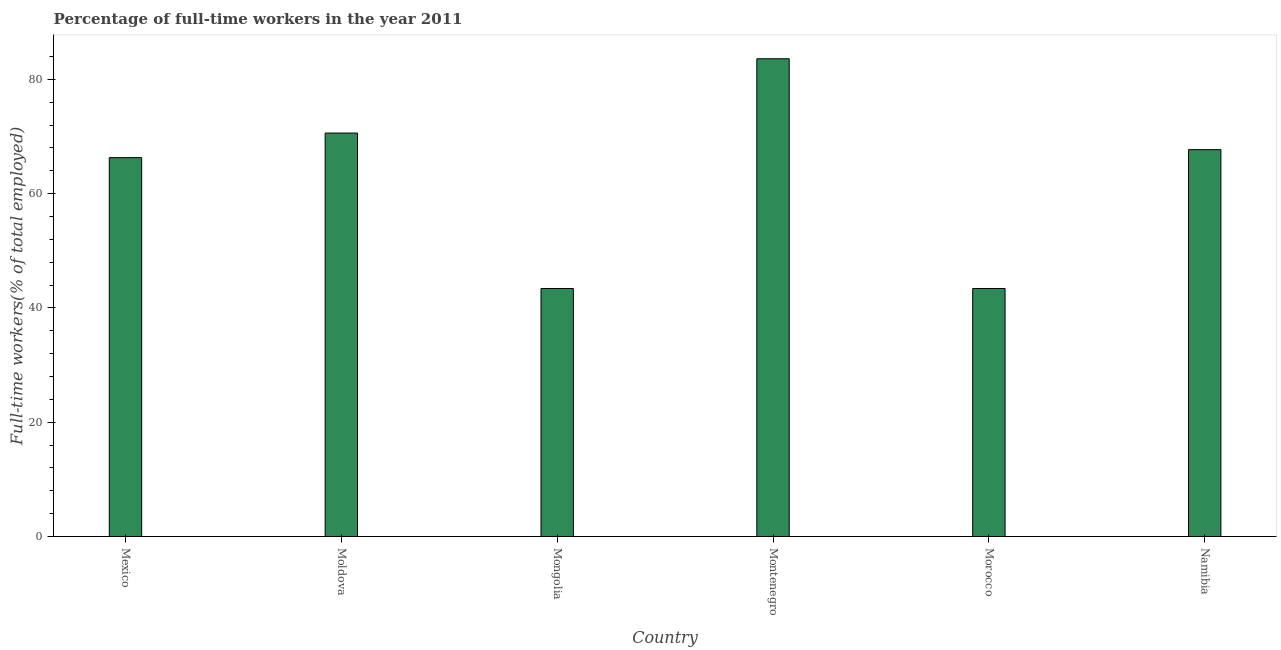Does the graph contain any zero values?
Make the answer very short. No. What is the title of the graph?
Give a very brief answer. Percentage of full-time workers in the year 2011. What is the label or title of the Y-axis?
Your response must be concise. Full-time workers(% of total employed). What is the percentage of full-time workers in Montenegro?
Provide a short and direct response. 83.6. Across all countries, what is the maximum percentage of full-time workers?
Your response must be concise. 83.6. Across all countries, what is the minimum percentage of full-time workers?
Your response must be concise. 43.4. In which country was the percentage of full-time workers maximum?
Your answer should be very brief. Montenegro. In which country was the percentage of full-time workers minimum?
Offer a terse response. Mongolia. What is the sum of the percentage of full-time workers?
Ensure brevity in your answer.  375. What is the difference between the percentage of full-time workers in Mongolia and Montenegro?
Offer a terse response. -40.2. What is the average percentage of full-time workers per country?
Keep it short and to the point. 62.5. What is the median percentage of full-time workers?
Ensure brevity in your answer.  67. In how many countries, is the percentage of full-time workers greater than 60 %?
Provide a succinct answer. 4. What is the ratio of the percentage of full-time workers in Moldova to that in Mongolia?
Your answer should be compact. 1.63. Is the percentage of full-time workers in Moldova less than that in Montenegro?
Provide a short and direct response. Yes. Is the difference between the percentage of full-time workers in Montenegro and Namibia greater than the difference between any two countries?
Your answer should be very brief. No. What is the difference between the highest and the lowest percentage of full-time workers?
Your answer should be very brief. 40.2. How many bars are there?
Offer a very short reply. 6. Are all the bars in the graph horizontal?
Your answer should be very brief. No. How many countries are there in the graph?
Your answer should be compact. 6. What is the Full-time workers(% of total employed) in Mexico?
Make the answer very short. 66.3. What is the Full-time workers(% of total employed) of Moldova?
Keep it short and to the point. 70.6. What is the Full-time workers(% of total employed) of Mongolia?
Give a very brief answer. 43.4. What is the Full-time workers(% of total employed) of Montenegro?
Provide a succinct answer. 83.6. What is the Full-time workers(% of total employed) in Morocco?
Your response must be concise. 43.4. What is the Full-time workers(% of total employed) in Namibia?
Your answer should be very brief. 67.7. What is the difference between the Full-time workers(% of total employed) in Mexico and Moldova?
Keep it short and to the point. -4.3. What is the difference between the Full-time workers(% of total employed) in Mexico and Mongolia?
Offer a terse response. 22.9. What is the difference between the Full-time workers(% of total employed) in Mexico and Montenegro?
Offer a terse response. -17.3. What is the difference between the Full-time workers(% of total employed) in Mexico and Morocco?
Your answer should be compact. 22.9. What is the difference between the Full-time workers(% of total employed) in Mexico and Namibia?
Your answer should be very brief. -1.4. What is the difference between the Full-time workers(% of total employed) in Moldova and Mongolia?
Offer a terse response. 27.2. What is the difference between the Full-time workers(% of total employed) in Moldova and Montenegro?
Your answer should be compact. -13. What is the difference between the Full-time workers(% of total employed) in Moldova and Morocco?
Your answer should be very brief. 27.2. What is the difference between the Full-time workers(% of total employed) in Mongolia and Montenegro?
Ensure brevity in your answer.  -40.2. What is the difference between the Full-time workers(% of total employed) in Mongolia and Namibia?
Offer a terse response. -24.3. What is the difference between the Full-time workers(% of total employed) in Montenegro and Morocco?
Keep it short and to the point. 40.2. What is the difference between the Full-time workers(% of total employed) in Morocco and Namibia?
Provide a succinct answer. -24.3. What is the ratio of the Full-time workers(% of total employed) in Mexico to that in Moldova?
Your response must be concise. 0.94. What is the ratio of the Full-time workers(% of total employed) in Mexico to that in Mongolia?
Your answer should be very brief. 1.53. What is the ratio of the Full-time workers(% of total employed) in Mexico to that in Montenegro?
Ensure brevity in your answer.  0.79. What is the ratio of the Full-time workers(% of total employed) in Mexico to that in Morocco?
Your answer should be compact. 1.53. What is the ratio of the Full-time workers(% of total employed) in Mexico to that in Namibia?
Offer a very short reply. 0.98. What is the ratio of the Full-time workers(% of total employed) in Moldova to that in Mongolia?
Keep it short and to the point. 1.63. What is the ratio of the Full-time workers(% of total employed) in Moldova to that in Montenegro?
Your answer should be very brief. 0.84. What is the ratio of the Full-time workers(% of total employed) in Moldova to that in Morocco?
Keep it short and to the point. 1.63. What is the ratio of the Full-time workers(% of total employed) in Moldova to that in Namibia?
Your answer should be very brief. 1.04. What is the ratio of the Full-time workers(% of total employed) in Mongolia to that in Montenegro?
Provide a succinct answer. 0.52. What is the ratio of the Full-time workers(% of total employed) in Mongolia to that in Morocco?
Offer a terse response. 1. What is the ratio of the Full-time workers(% of total employed) in Mongolia to that in Namibia?
Give a very brief answer. 0.64. What is the ratio of the Full-time workers(% of total employed) in Montenegro to that in Morocco?
Provide a succinct answer. 1.93. What is the ratio of the Full-time workers(% of total employed) in Montenegro to that in Namibia?
Your response must be concise. 1.24. What is the ratio of the Full-time workers(% of total employed) in Morocco to that in Namibia?
Offer a terse response. 0.64. 